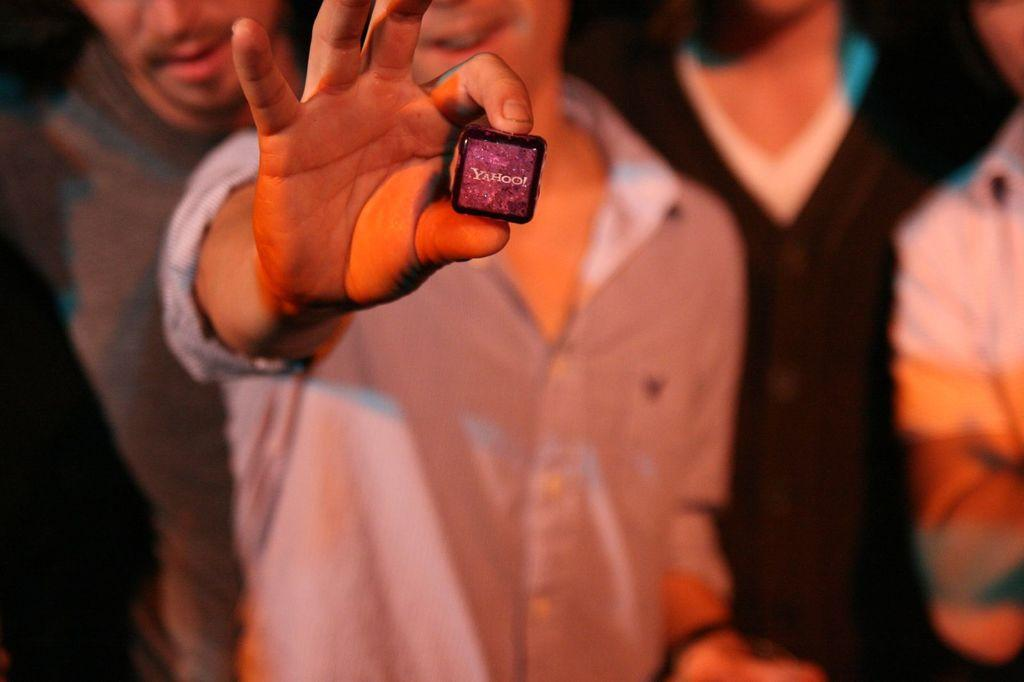How many people are in the image? There are four persons in the image. Can you describe what one of the men is doing? One of the men is holding an object. What can be seen on the object being held? There is text on the object being held. What type of weather can be seen in the image? There is no information about the weather in the image. Are there any pests visible in the image? There is no mention of pests in the image. 